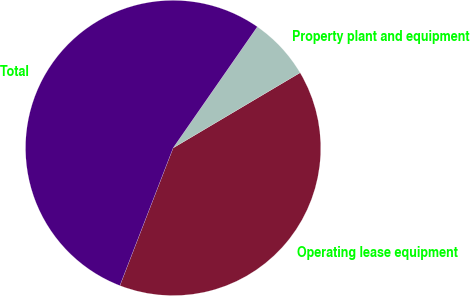Convert chart to OTSL. <chart><loc_0><loc_0><loc_500><loc_500><pie_chart><fcel>Operating lease equipment<fcel>Property plant and equipment<fcel>Total<nl><fcel>39.39%<fcel>6.82%<fcel>53.79%<nl></chart> 